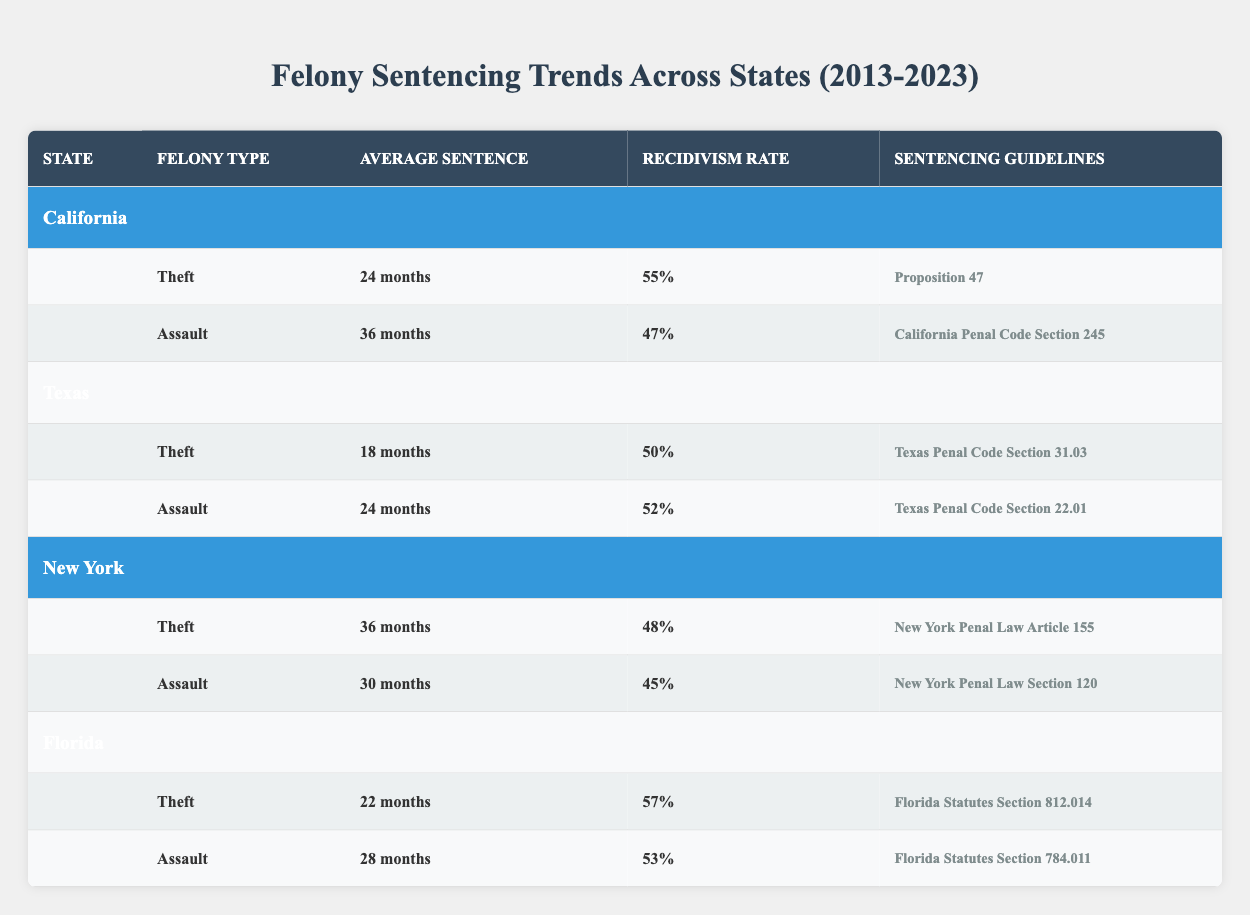What is the average sentence duration for Theft in California? The table states that the average sentence duration for Theft in California is 24 months. Therefore, the answer can be directly retrieved from the relevant row in the table.
Answer: 24 months How many states have an average recidivism rate above 50% for Assault? The recidivism rates for Assault in the states are as follows: California (47%), Texas (52%), New York (45%), and Florida (53%). Only Texas and Florida have rates above 50%. Therefore, there are 2 states.
Answer: 2 What is the average recidivism rate for Theft across all states presented? The recidivism rates for Theft are: California (55%), Texas (50%), New York (48%), and Florida (57%). The average is calculated as (55 + 50 + 48 + 57) / 4 = 52.5%.
Answer: 52.5% True or False: New York has a higher average sentence for Assault compared to Texas. The average sentence for Assault in New York is 30 months, while in Texas, it is 24 months. Since 30 is greater than 24, the statement is true.
Answer: True Which state has the lowest average sentence for Theft, and what is that duration? The average sentences for Theft are as follows: California (24 months), Texas (18 months), New York (36 months), and Florida (22 months). Texas has the lowest average sentence of 18 months for Theft.
Answer: Texas, 18 months What is the total average sentence duration for Assault in Florida and Texas combined? The average sentence for Assault in Florida is 28 months and in Texas is 24 months. The total duration is 28 + 24 = 52 months.
Answer: 52 months How does the recidivism rate for Assault in Florida compare to that in New York? According to the table, Florida has a recidivism rate of 53% for Assault and New York has a rate of 45%. Since 53% is greater than 45%, Florida's rate is higher.
Answer: Florida's is higher What is the average sentence duration for Assault across all states? The average sentence durations for Assault are: California (36 months), Texas (24 months), New York (30 months), and Florida (28 months). The average is (36 + 24 + 30 + 28) / 4 = 29.5 months.
Answer: 29.5 months 